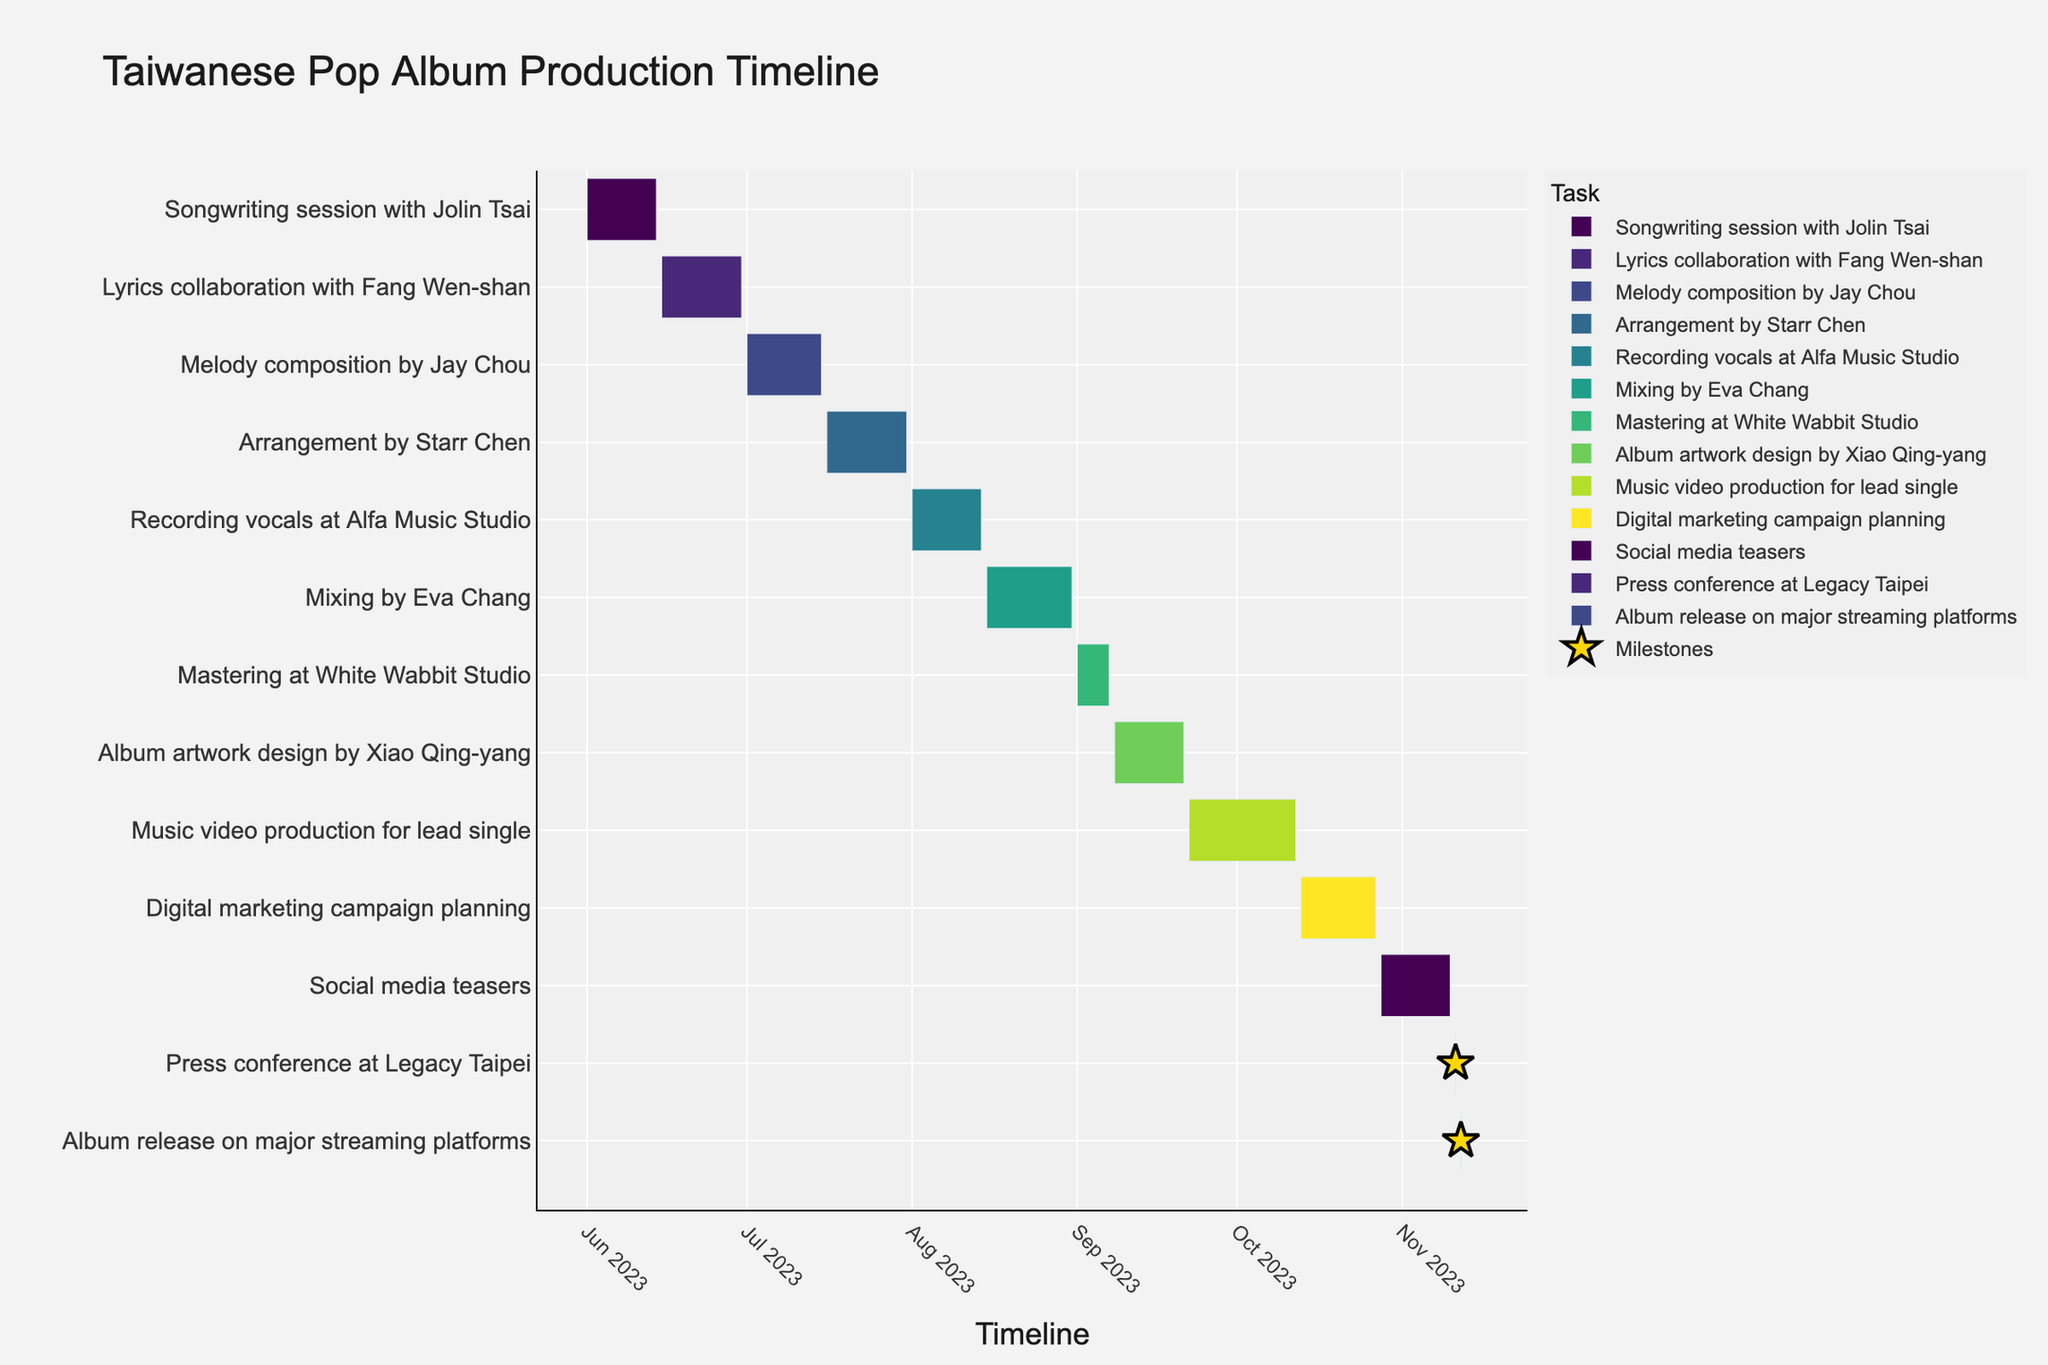What's the title of the chart? The title is given at the top of the chart and usually summarizes the chart's main content or purpose.
Answer: Taiwanese Pop Album Production Timeline What is the duration for the Songwriting session with Jolin Tsai? Duration can be found by subtracting the start date from the end date of the task. The start date is June 1, 2023, and the end date is June 14, 2023. Hence, the duration is 14 days.
Answer: 14 days Which task takes place immediately before the recording of vocals? Look at the task listed before "Recording vocals at Alfa Music Studio" in the chart. It's "Arrangement by Starr Chen," which ends on July 31, 2023, just before the recording starts on August 1, 2023.
Answer: Arrangement by Starr Chen What is the shortest task duration in the project? To find the shortest task, check the duration of each task. "Press conference at Legacy Taipei" and "Album release on major streaming platforms" are both single-day events on November 11, 2023, and November 12, 2023, respectively.
Answer: Press conference at Legacy Taipei or Album release on major streaming platforms What is the total duration of the recording phase, including mixing and mastering? Total duration includes adding up the durations of "Recording vocals at Alfa Music Studio," "Mixing by Eva Chang," and "Mastering at White Wabbit Studio." The durations are from August 1 to August 14 (14 days), August 15 to August 31 (17 days), and September 1 to September 7 (7 days). Therefore, the total duration is 14 + 17 + 7 = 38 days.
Answer: 38 days Which task has the longest duration? Check the duration of each task and identify the one with the longest duration. "Music video production for lead single" runs from September 22 to October 12, 2023, lasting 21 days, which is the longest among all the tasks.
Answer: Music video production for lead single How many tasks overlap with the Digital marketing campaign planning? "Digital marketing campaign planning" runs from October 13, 2023, to October 27, 2023. During this period, "Music video production for lead single" (ending on October 12, 2023) ends just before its start, and "Social media teasers" (from October 28 to November 10, 2023) starts immediately after it. Therefore, no tasks overlap with the Digital marketing campaign planning.
Answer: None 